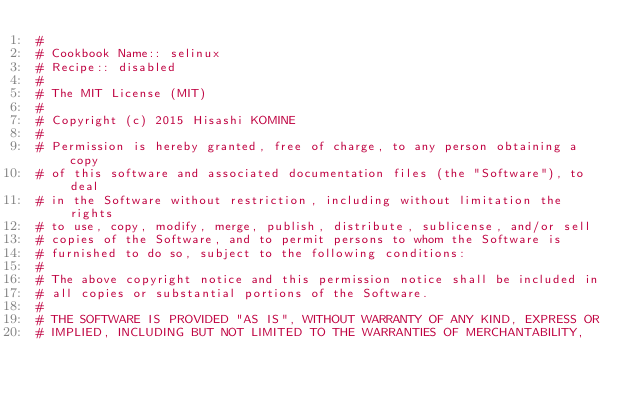Convert code to text. <code><loc_0><loc_0><loc_500><loc_500><_Ruby_>#
# Cookbook Name:: selinux
# Recipe:: disabled
#
# The MIT License (MIT)
# 
# Copyright (c) 2015 Hisashi KOMINE
# 
# Permission is hereby granted, free of charge, to any person obtaining a copy
# of this software and associated documentation files (the "Software"), to deal
# in the Software without restriction, including without limitation the rights
# to use, copy, modify, merge, publish, distribute, sublicense, and/or sell
# copies of the Software, and to permit persons to whom the Software is
# furnished to do so, subject to the following conditions:
# 
# The above copyright notice and this permission notice shall be included in
# all copies or substantial portions of the Software.
# 
# THE SOFTWARE IS PROVIDED "AS IS", WITHOUT WARRANTY OF ANY KIND, EXPRESS OR
# IMPLIED, INCLUDING BUT NOT LIMITED TO THE WARRANTIES OF MERCHANTABILITY,</code> 